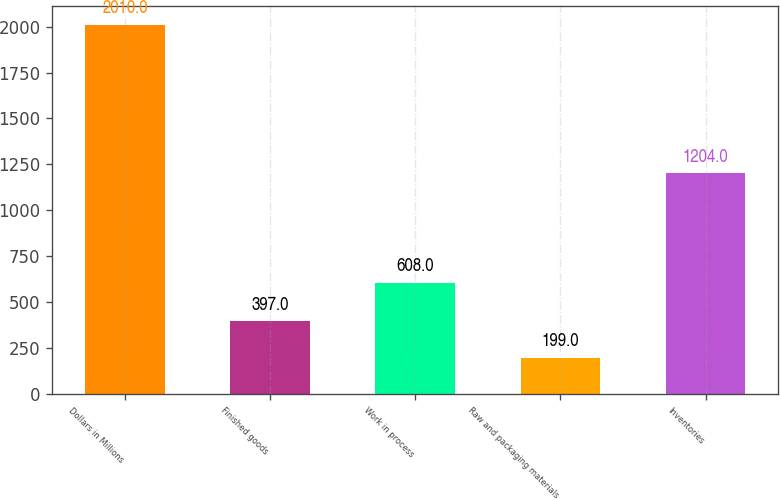Convert chart to OTSL. <chart><loc_0><loc_0><loc_500><loc_500><bar_chart><fcel>Dollars in Millions<fcel>Finished goods<fcel>Work in process<fcel>Raw and packaging materials<fcel>Inventories<nl><fcel>2010<fcel>397<fcel>608<fcel>199<fcel>1204<nl></chart> 